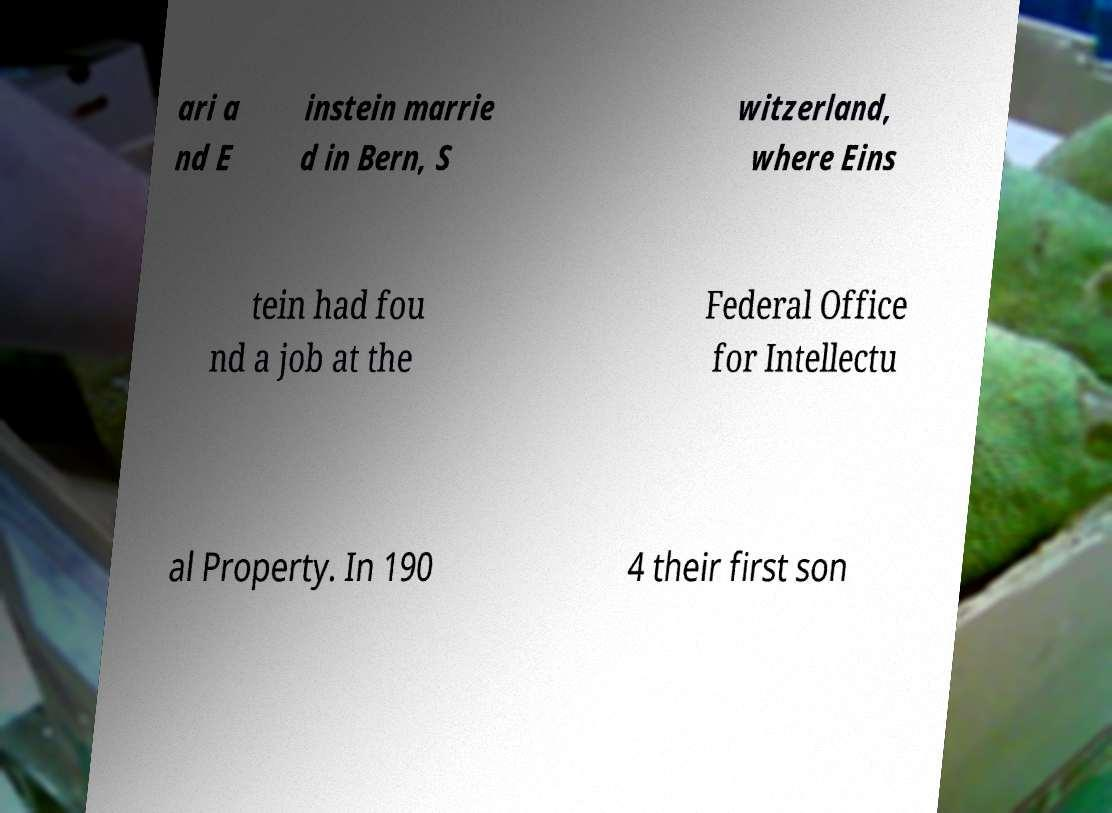I need the written content from this picture converted into text. Can you do that? ari a nd E instein marrie d in Bern, S witzerland, where Eins tein had fou nd a job at the Federal Office for Intellectu al Property. In 190 4 their first son 